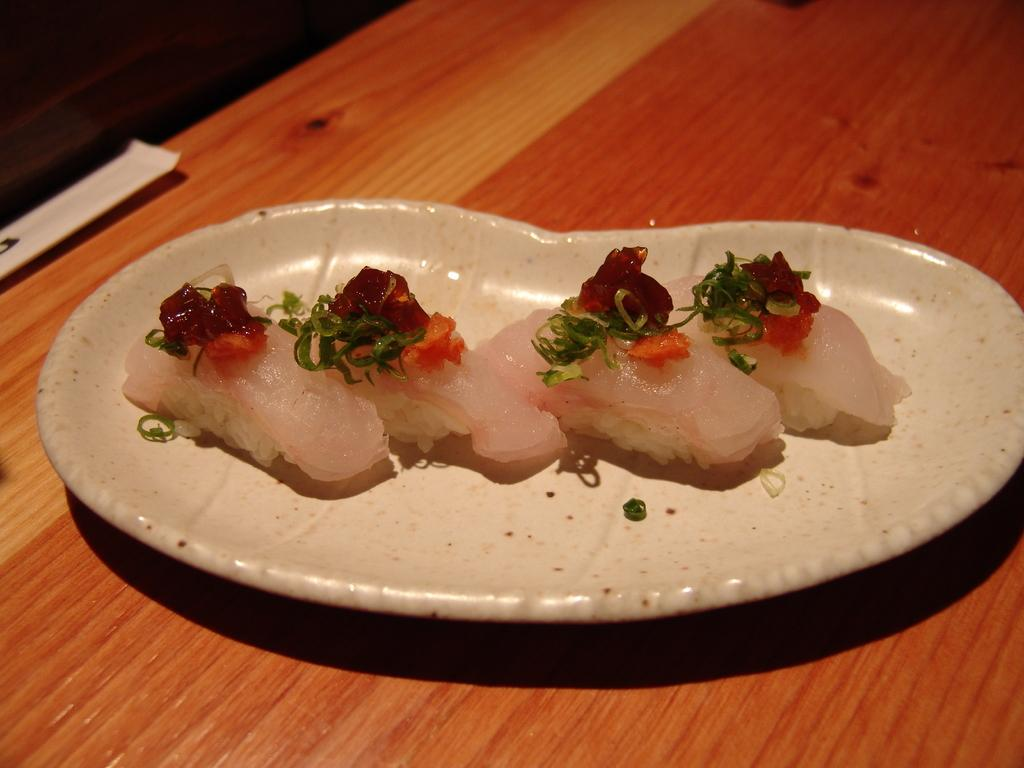What is present on the plate in the image? There are food items on the plate in the image. What is the color of the plate? The plate is white in color. On what surface is the plate placed? The plate is on a wooden surface. How much payment is required for the nut on the plate in the image? There is no nut present on the plate in the image, and therefore no payment is required. 